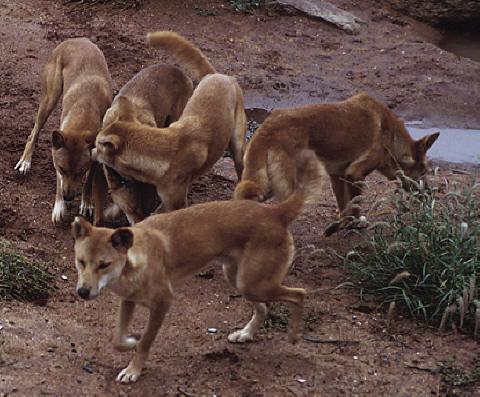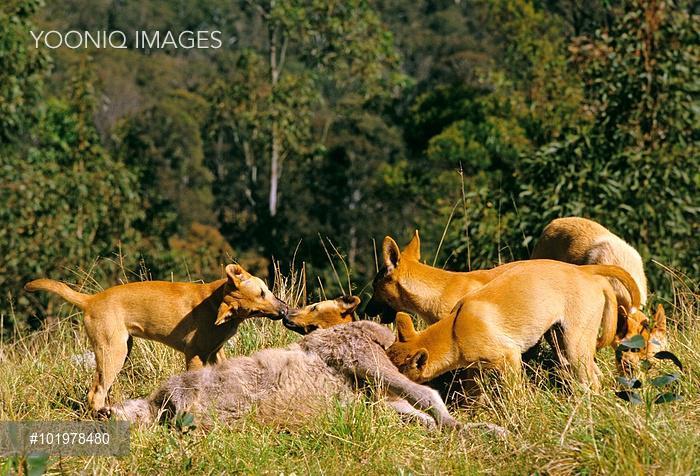The first image is the image on the left, the second image is the image on the right. For the images shown, is this caption "Each image contains exactly one wild dog." true? Answer yes or no. No. The first image is the image on the left, the second image is the image on the right. Evaluate the accuracy of this statement regarding the images: "Two wild dogs are out in the wild near a wooded area.". Is it true? Answer yes or no. No. 